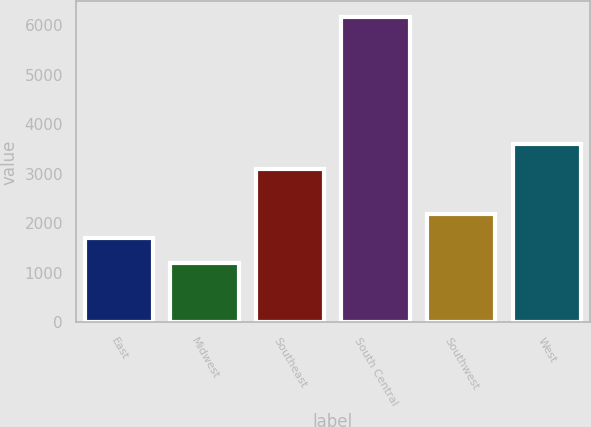Convert chart to OTSL. <chart><loc_0><loc_0><loc_500><loc_500><bar_chart><fcel>East<fcel>Midwest<fcel>Southeast<fcel>South Central<fcel>Southwest<fcel>West<nl><fcel>1695.4<fcel>1198<fcel>3107<fcel>6172<fcel>2192.8<fcel>3604.4<nl></chart> 